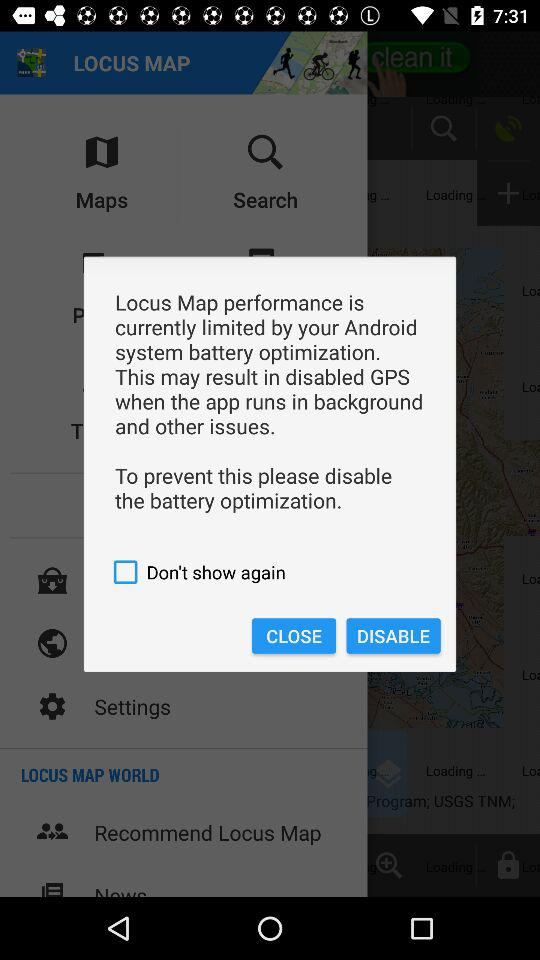What is the name of the application? The application name is "LOCUS MAP". 